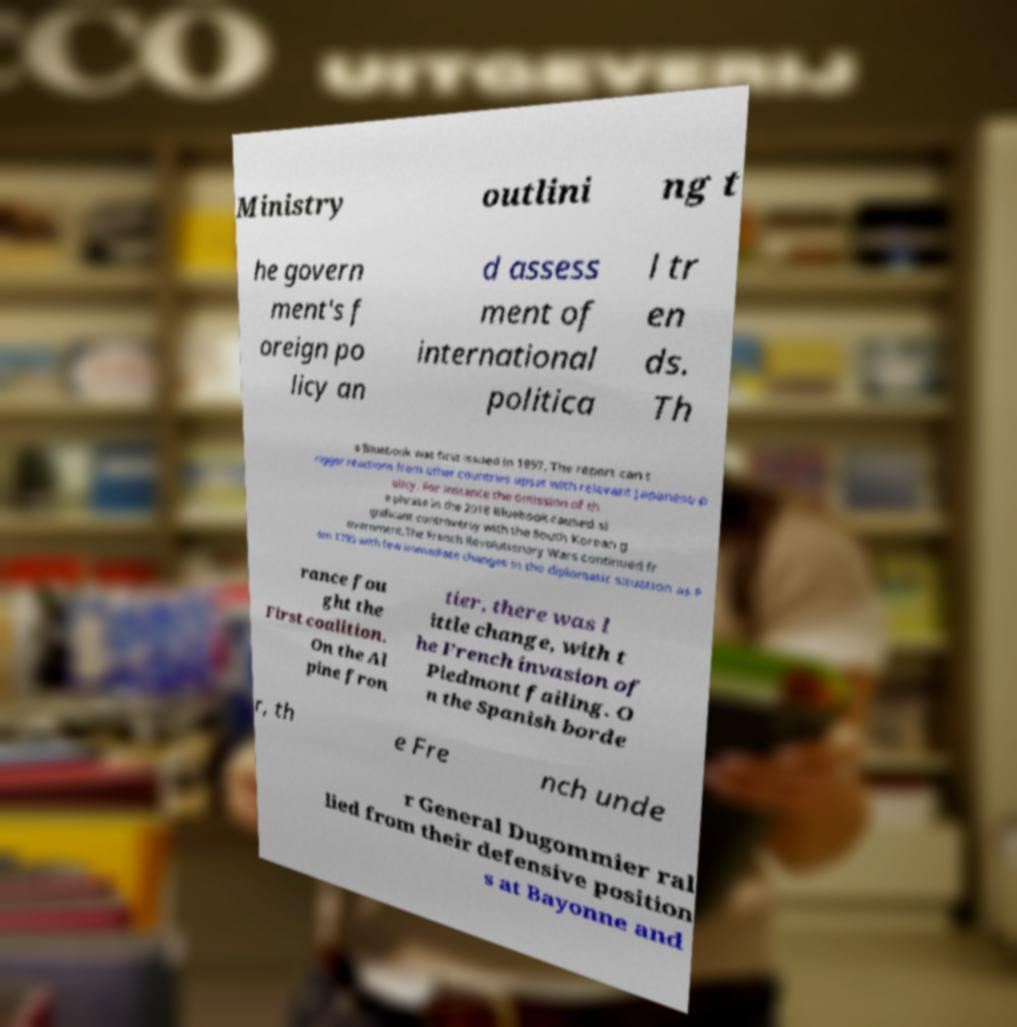I need the written content from this picture converted into text. Can you do that? Ministry outlini ng t he govern ment's f oreign po licy an d assess ment of international politica l tr en ds. Th e Bluebook was first issued in 1957. The report can t rigger reactions from other countries upset with relevant Japanese p olicy. For instance the omission of th e phrase in the 2018 Bluebook caused si gnificant controversy with the South Korean g overnment.The French Revolutionary Wars continued fr om 1793 with few immediate changes in the diplomatic situation as F rance fou ght the First coalition. On the Al pine fron tier, there was l ittle change, with t he French invasion of Piedmont failing. O n the Spanish borde r, th e Fre nch unde r General Dugommier ral lied from their defensive position s at Bayonne and 